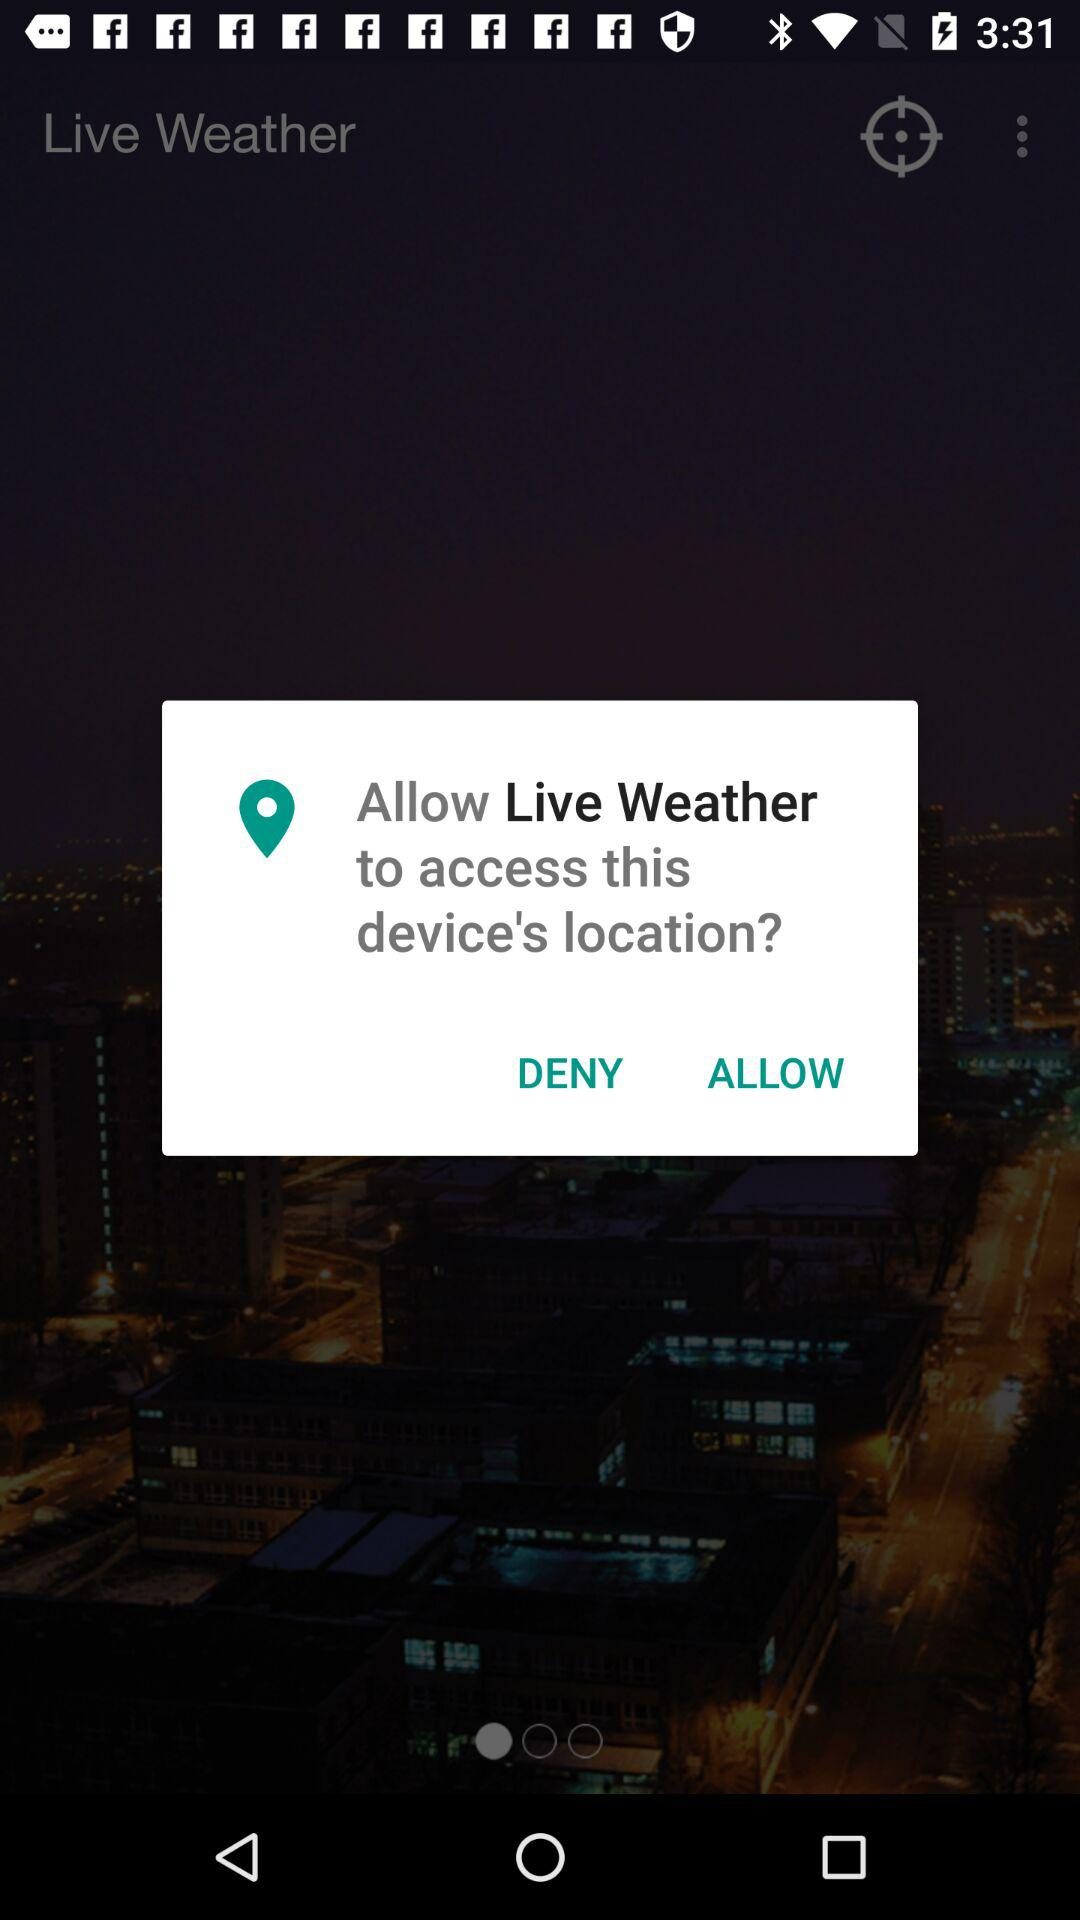What is the application name? The application name is "Live Weather". 